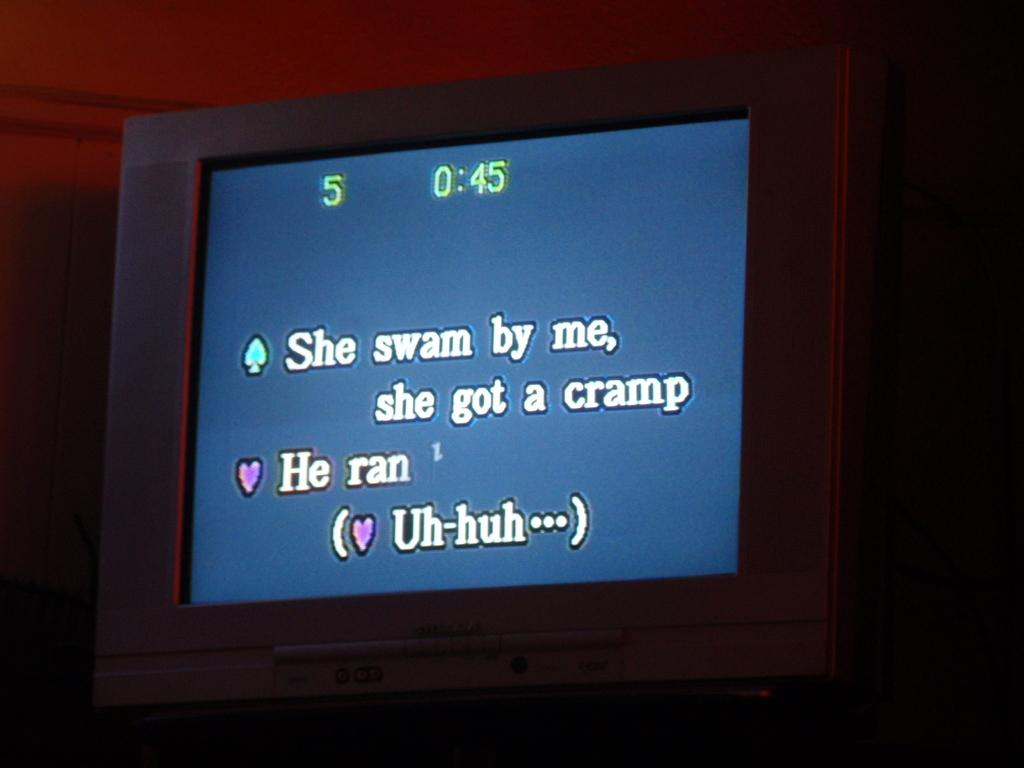<image>
Offer a succinct explanation of the picture presented. The words on a monitor say "She swam by me, she got a cramp". 